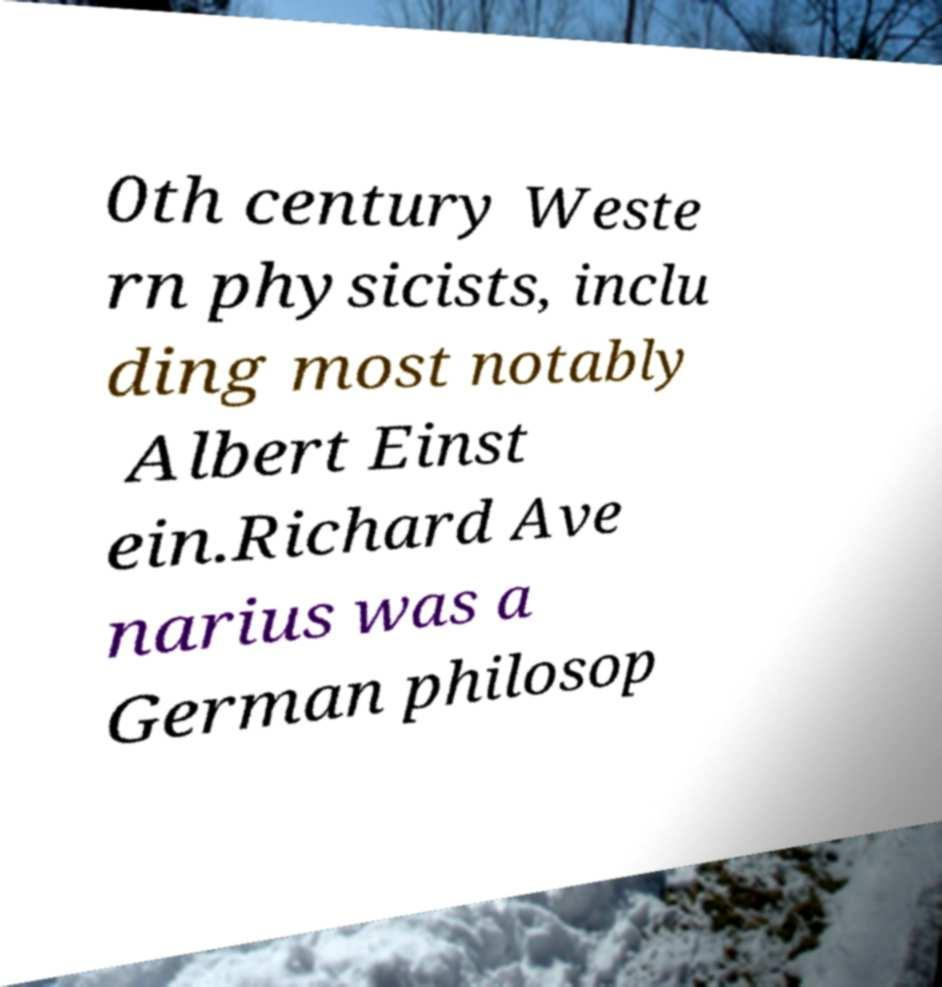Please read and relay the text visible in this image. What does it say? 0th century Weste rn physicists, inclu ding most notably Albert Einst ein.Richard Ave narius was a German philosop 